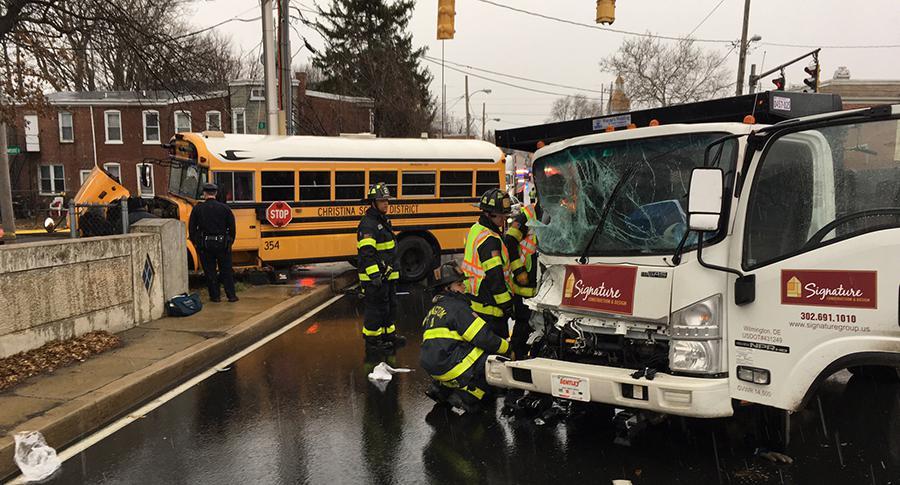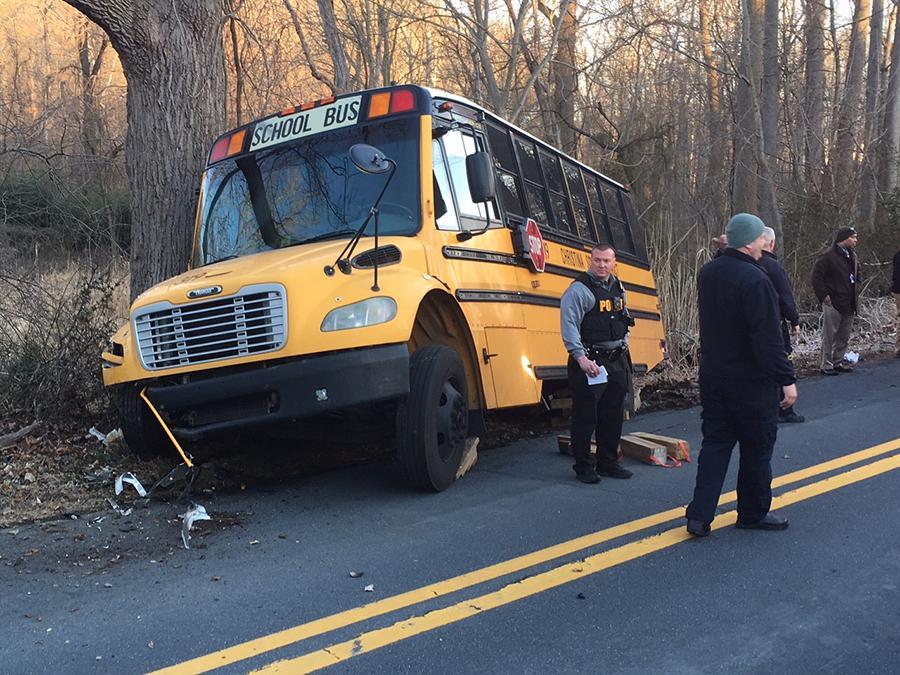The first image is the image on the left, the second image is the image on the right. Examine the images to the left and right. Is the description "A white truck is visible in the left image." accurate? Answer yes or no. Yes. The first image is the image on the left, the second image is the image on the right. For the images displayed, is the sentence "In one of the images you can see firemen tending to an accident between a school bus and a white truck." factually correct? Answer yes or no. Yes. 